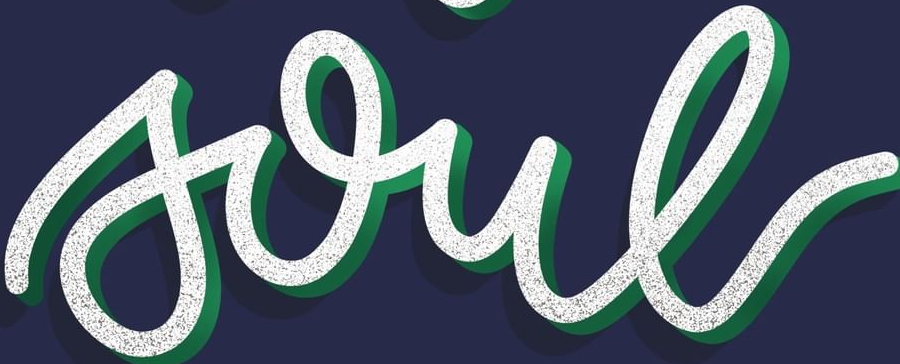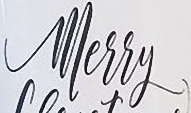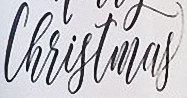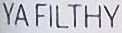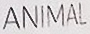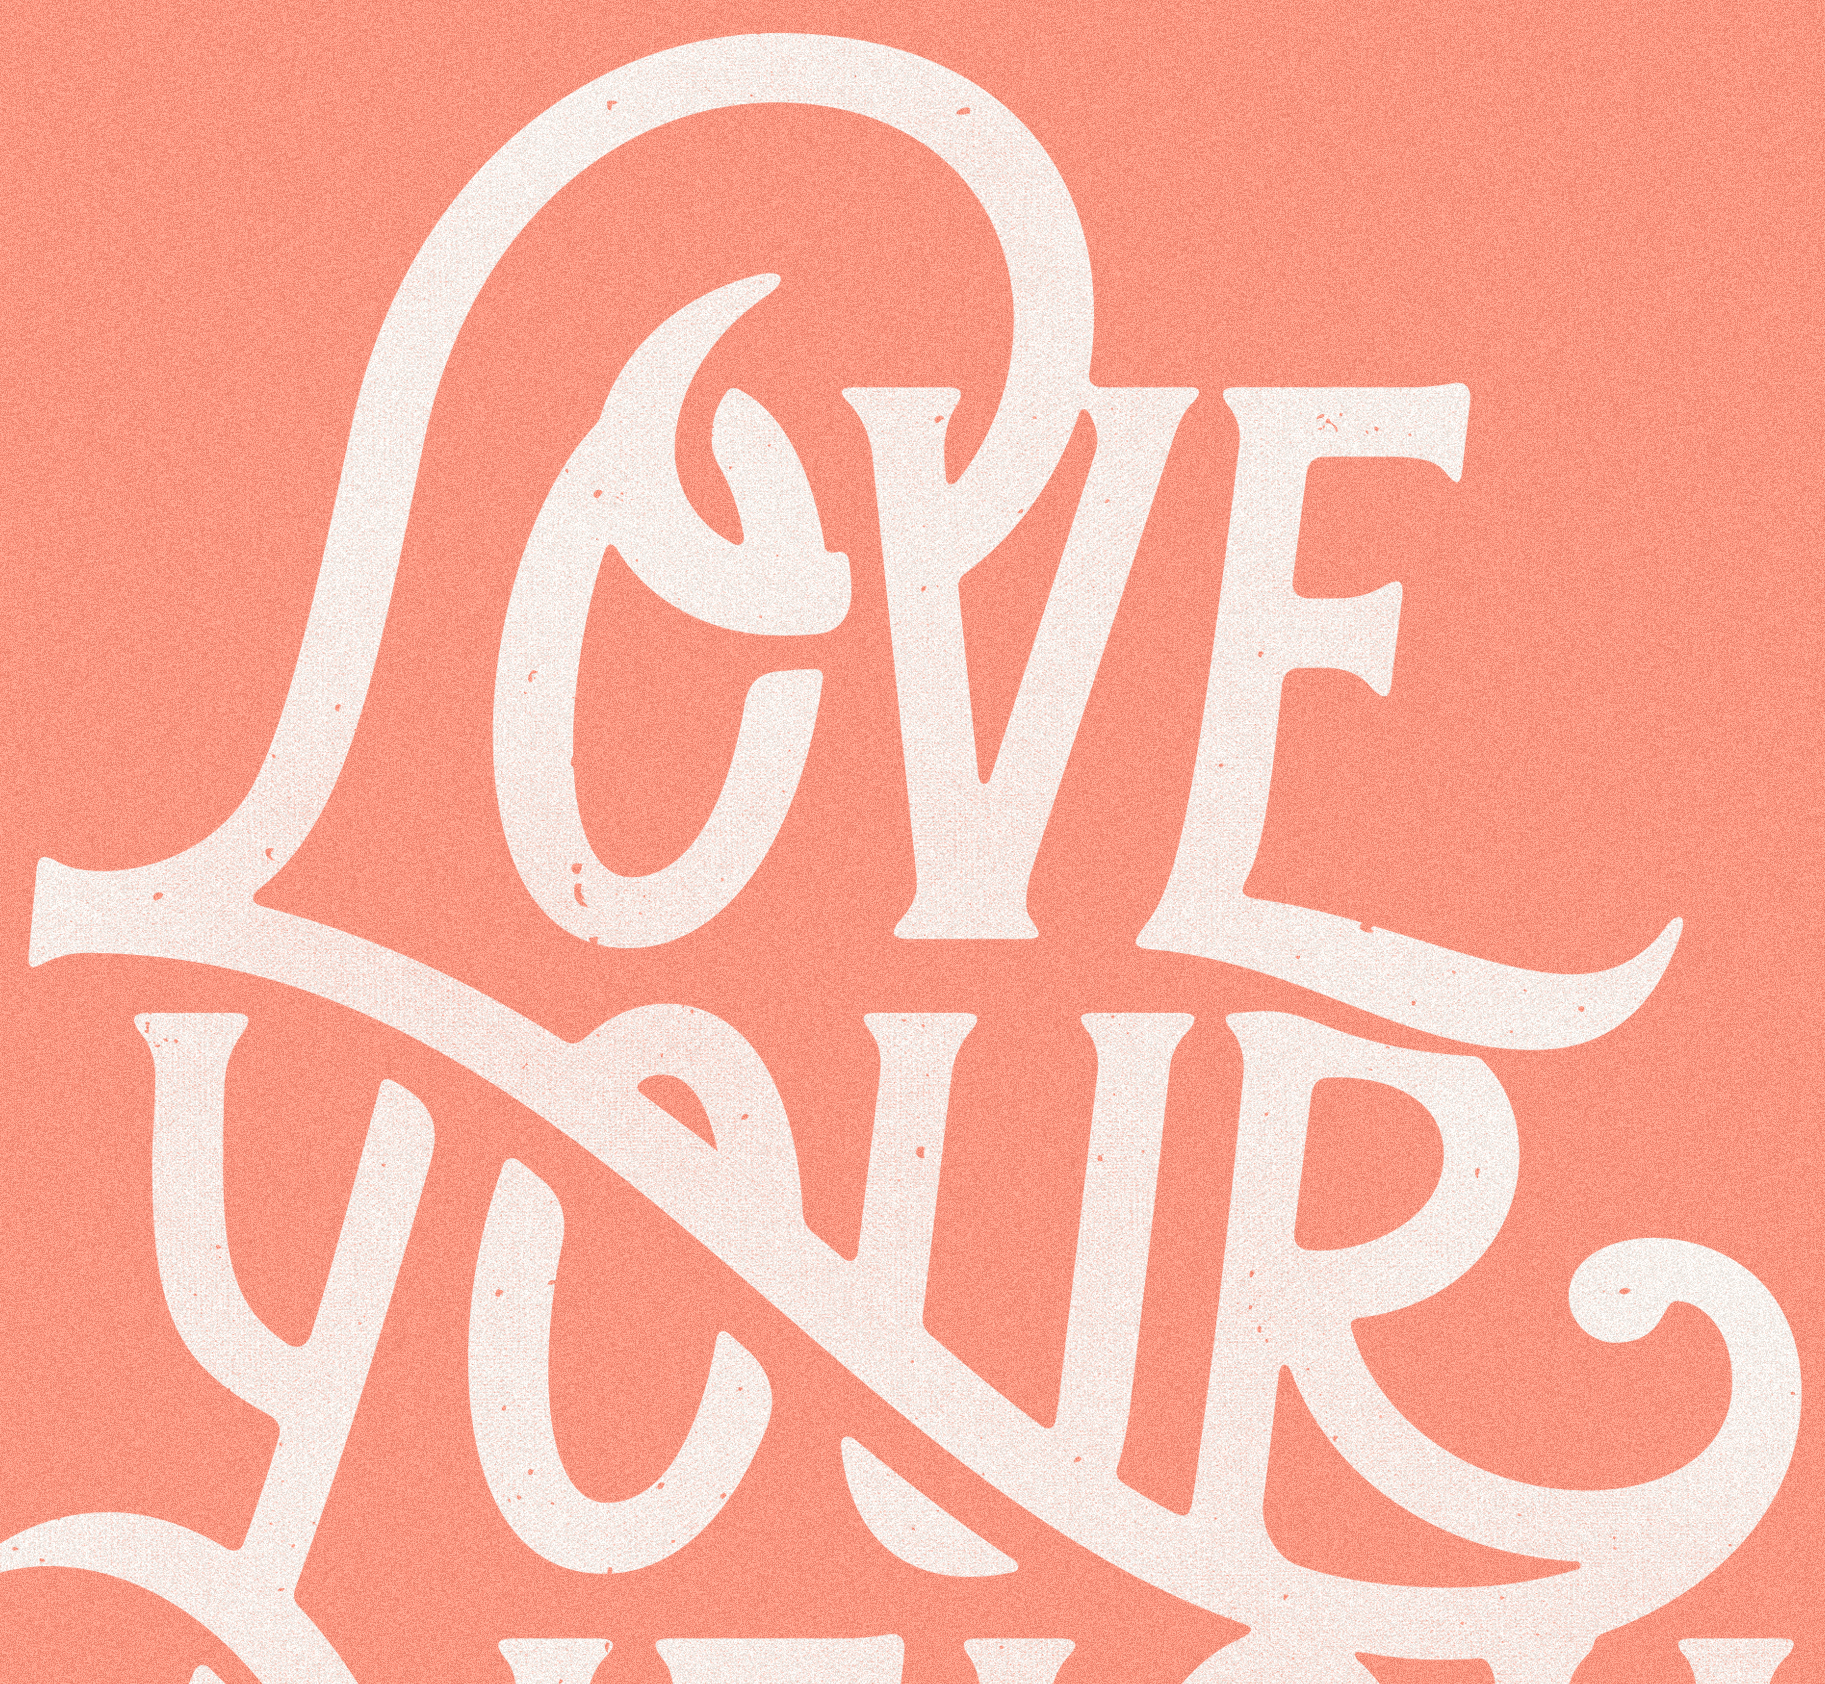What text appears in these images from left to right, separated by a semicolon? soul; Merry; Christmas; YAFILTHY; ANIMAL; LOVE 